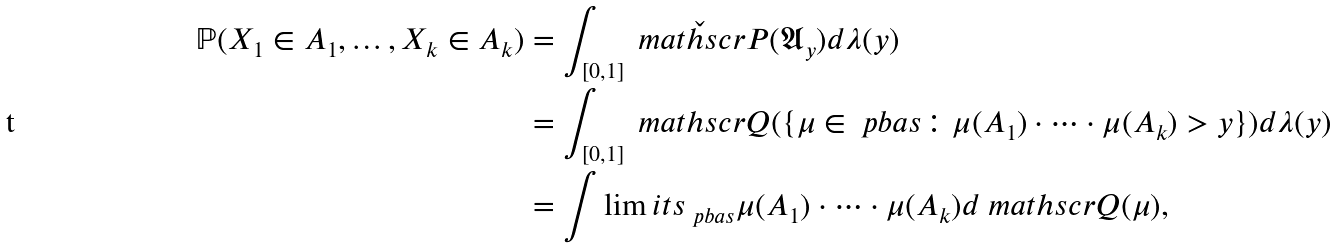Convert formula to latex. <formula><loc_0><loc_0><loc_500><loc_500>\mathbb { P } ( X _ { 1 } \in A _ { 1 } , \dots , X _ { k } \in A _ { k } ) & = \int _ { [ 0 , 1 ] } \check { \ m a t h s c r { P } } ( { \mathfrak { A } _ { y } } ) d \lambda ( y ) \\ & = \int _ { [ 0 , 1 ] } \ m a t h s c r { Q } ( \{ \mu \in \ p b a s \colon \mu ( A _ { 1 } ) \cdot \dots \cdot \mu ( A _ { k } ) > y \} ) d \lambda ( y ) \\ & = \int \lim i t s _ { \ p b a s } \mu ( A _ { 1 } ) \cdot \dots \cdot \mu ( A _ { k } ) d \ m a t h s c r { Q } ( \mu ) ,</formula> 